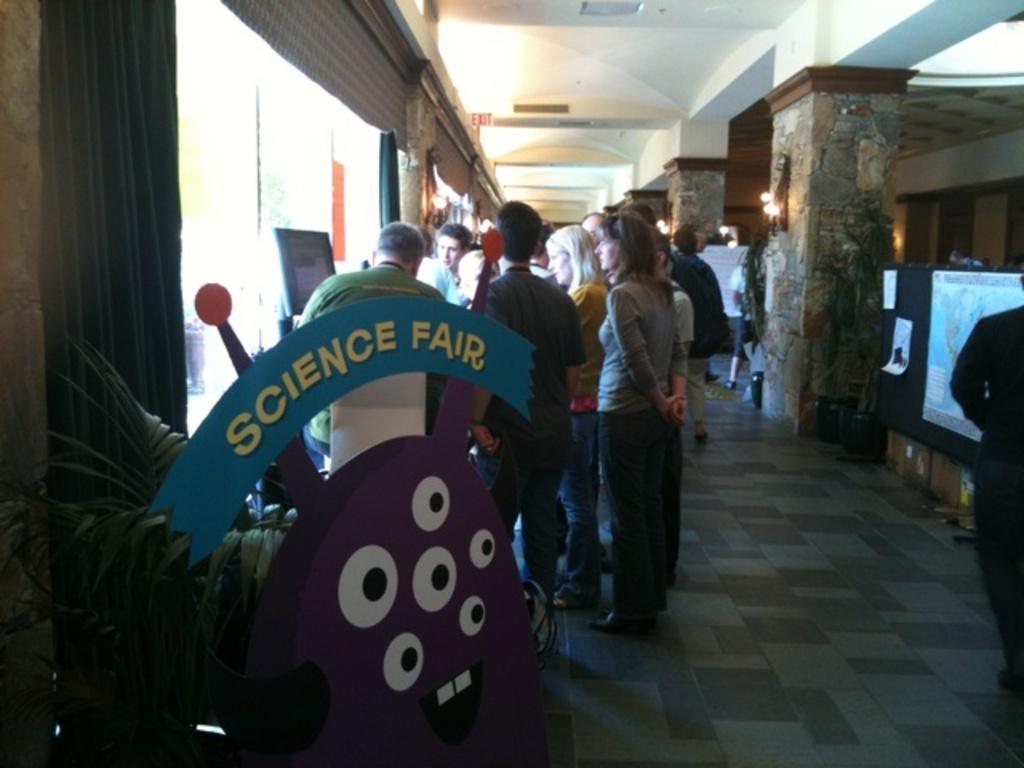How would you summarize this image in a sentence or two? In this picture I can observe some people standing on the floor. There are men and women in this picture. On the left side I can observe a plant. On the right side there are pillars. 